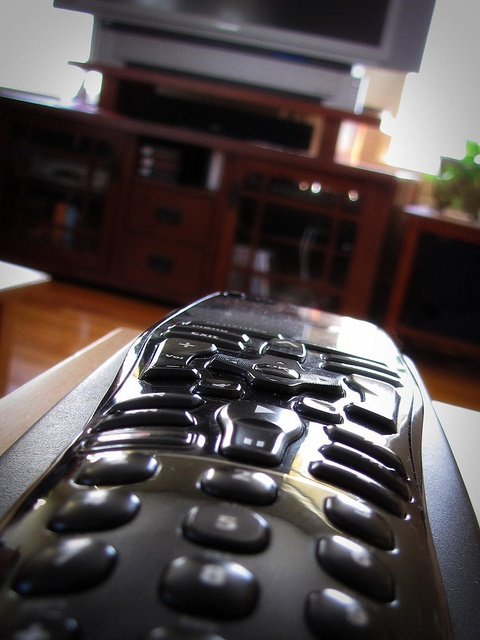Describe the objects in this image and their specific colors. I can see remote in darkgray, black, gray, and white tones and tv in darkgray, gray, and black tones in this image. 